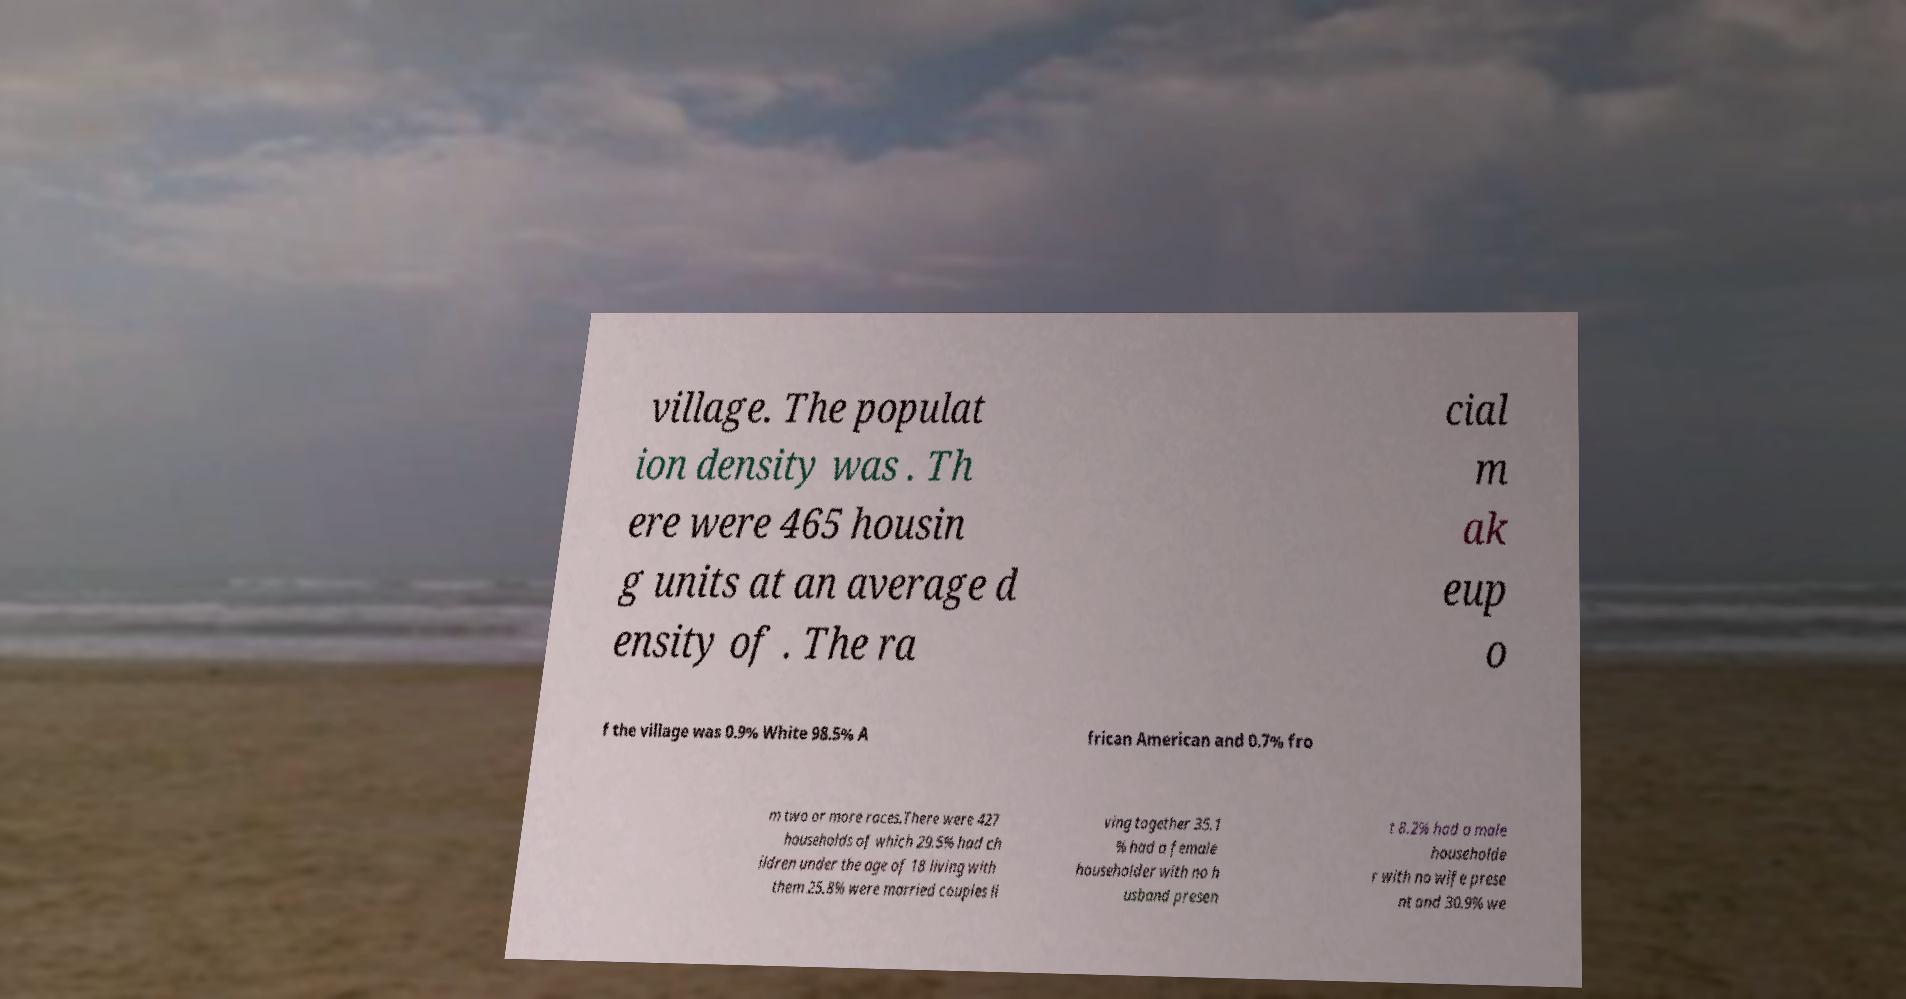Could you extract and type out the text from this image? village. The populat ion density was . Th ere were 465 housin g units at an average d ensity of . The ra cial m ak eup o f the village was 0.9% White 98.5% A frican American and 0.7% fro m two or more races.There were 427 households of which 29.5% had ch ildren under the age of 18 living with them 25.8% were married couples li ving together 35.1 % had a female householder with no h usband presen t 8.2% had a male householde r with no wife prese nt and 30.9% we 